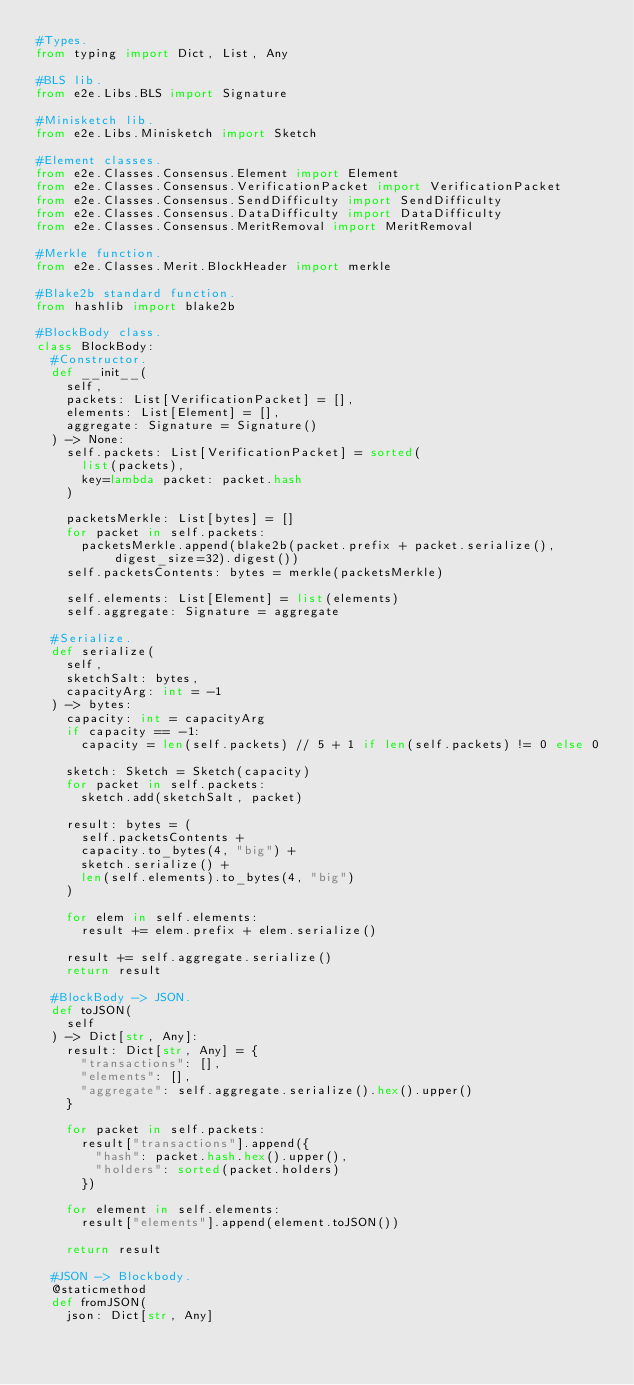Convert code to text. <code><loc_0><loc_0><loc_500><loc_500><_Python_>#Types.
from typing import Dict, List, Any

#BLS lib.
from e2e.Libs.BLS import Signature

#Minisketch lib.
from e2e.Libs.Minisketch import Sketch

#Element classes.
from e2e.Classes.Consensus.Element import Element
from e2e.Classes.Consensus.VerificationPacket import VerificationPacket
from e2e.Classes.Consensus.SendDifficulty import SendDifficulty
from e2e.Classes.Consensus.DataDifficulty import DataDifficulty
from e2e.Classes.Consensus.MeritRemoval import MeritRemoval

#Merkle function.
from e2e.Classes.Merit.BlockHeader import merkle

#Blake2b standard function.
from hashlib import blake2b

#BlockBody class.
class BlockBody:
  #Constructor.
  def __init__(
    self,
    packets: List[VerificationPacket] = [],
    elements: List[Element] = [],
    aggregate: Signature = Signature()
  ) -> None:
    self.packets: List[VerificationPacket] = sorted(
      list(packets),
      key=lambda packet: packet.hash
    )

    packetsMerkle: List[bytes] = []
    for packet in self.packets:
      packetsMerkle.append(blake2b(packet.prefix + packet.serialize(), digest_size=32).digest())
    self.packetsContents: bytes = merkle(packetsMerkle)

    self.elements: List[Element] = list(elements)
    self.aggregate: Signature = aggregate

  #Serialize.
  def serialize(
    self,
    sketchSalt: bytes,
    capacityArg: int = -1
  ) -> bytes:
    capacity: int = capacityArg
    if capacity == -1:
      capacity = len(self.packets) // 5 + 1 if len(self.packets) != 0 else 0

    sketch: Sketch = Sketch(capacity)
    for packet in self.packets:
      sketch.add(sketchSalt, packet)

    result: bytes = (
      self.packetsContents +
      capacity.to_bytes(4, "big") +
      sketch.serialize() +
      len(self.elements).to_bytes(4, "big")
    )

    for elem in self.elements:
      result += elem.prefix + elem.serialize()

    result += self.aggregate.serialize()
    return result

  #BlockBody -> JSON.
  def toJSON(
    self
  ) -> Dict[str, Any]:
    result: Dict[str, Any] = {
      "transactions": [],
      "elements": [],
      "aggregate": self.aggregate.serialize().hex().upper()
    }

    for packet in self.packets:
      result["transactions"].append({
        "hash": packet.hash.hex().upper(),
        "holders": sorted(packet.holders)
      })

    for element in self.elements:
      result["elements"].append(element.toJSON())

    return result

  #JSON -> Blockbody.
  @staticmethod
  def fromJSON(
    json: Dict[str, Any]</code> 